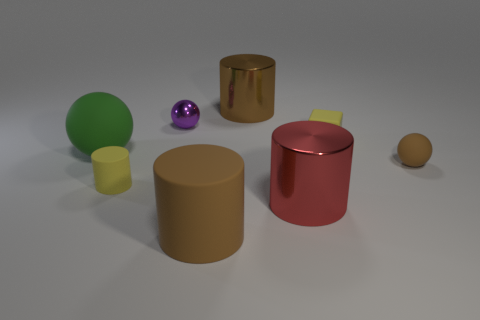The tiny matte thing that is the same shape as the large red metal object is what color? The small object sharing the same cylindrical shape as the large red one appears to be a shade of brown, similar to beige or light tan. 